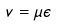<formula> <loc_0><loc_0><loc_500><loc_500>v = \mu \epsilon</formula> 